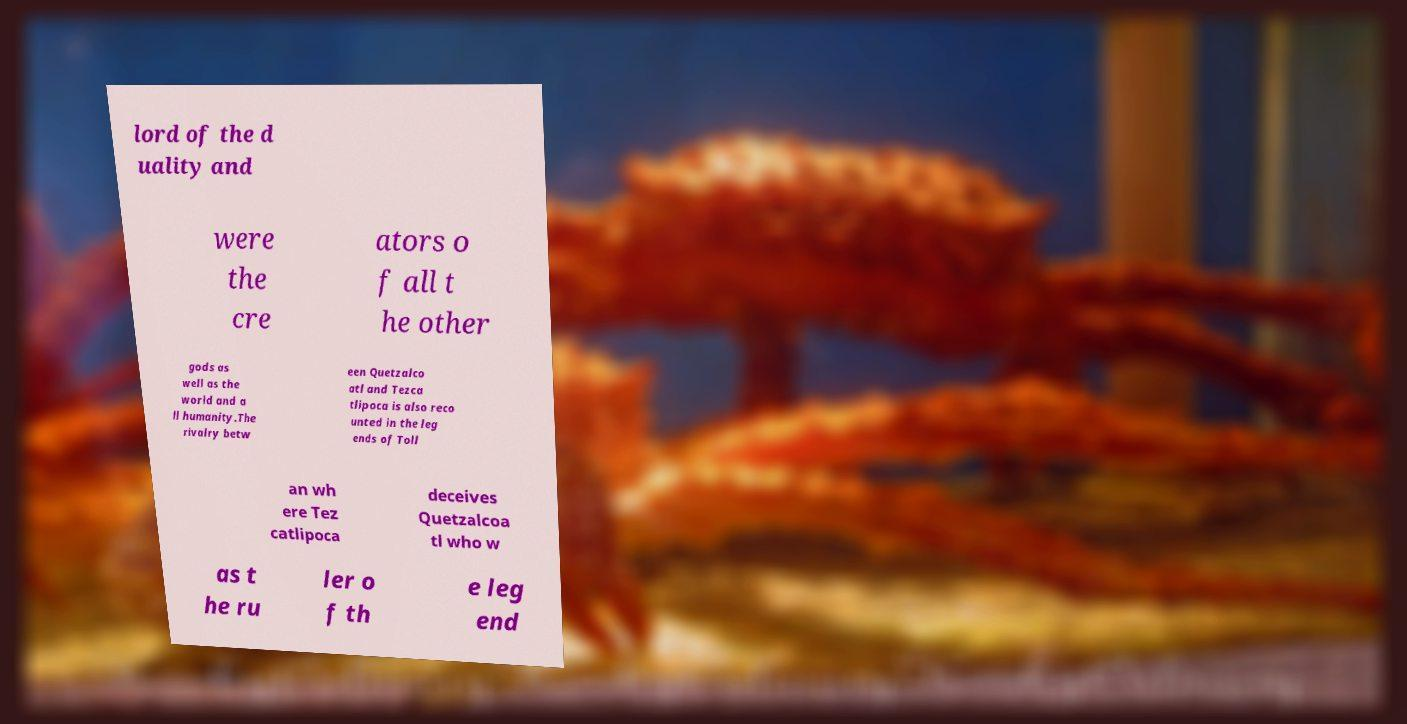Can you accurately transcribe the text from the provided image for me? lord of the d uality and were the cre ators o f all t he other gods as well as the world and a ll humanity.The rivalry betw een Quetzalco atl and Tezca tlipoca is also reco unted in the leg ends of Toll an wh ere Tez catlipoca deceives Quetzalcoa tl who w as t he ru ler o f th e leg end 